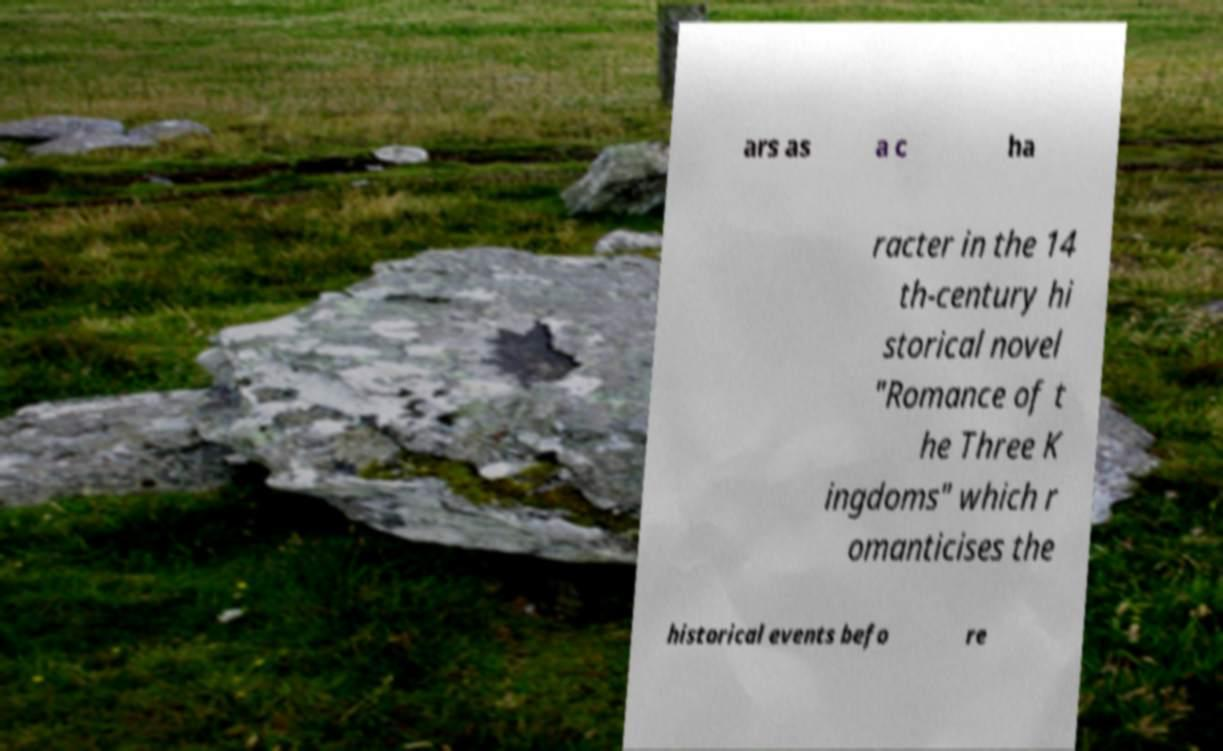I need the written content from this picture converted into text. Can you do that? ars as a c ha racter in the 14 th-century hi storical novel "Romance of t he Three K ingdoms" which r omanticises the historical events befo re 